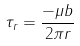<formula> <loc_0><loc_0><loc_500><loc_500>\tau _ { r } = \frac { - \mu b } { 2 \pi r }</formula> 